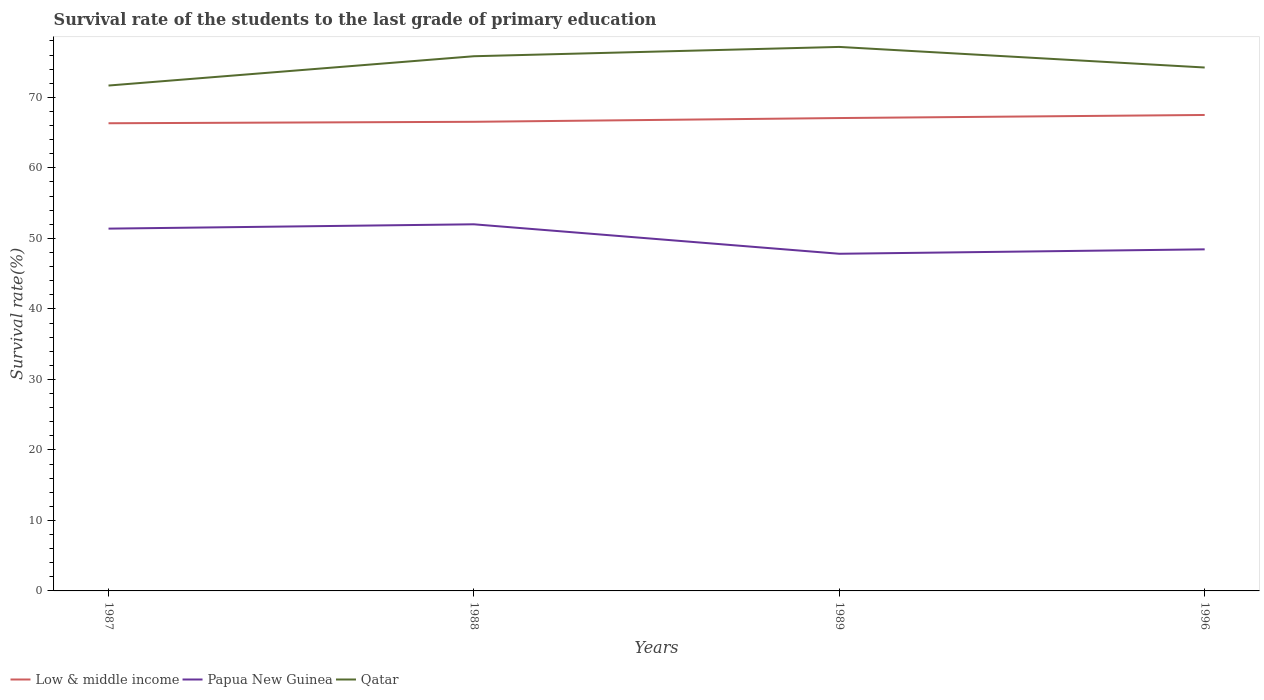Does the line corresponding to Papua New Guinea intersect with the line corresponding to Qatar?
Keep it short and to the point. No. Across all years, what is the maximum survival rate of the students in Qatar?
Your answer should be compact. 71.68. What is the total survival rate of the students in Qatar in the graph?
Offer a very short reply. 1.6. What is the difference between the highest and the second highest survival rate of the students in Papua New Guinea?
Offer a very short reply. 4.18. How many lines are there?
Make the answer very short. 3. What is the difference between two consecutive major ticks on the Y-axis?
Your response must be concise. 10. How many legend labels are there?
Provide a short and direct response. 3. How are the legend labels stacked?
Your answer should be very brief. Horizontal. What is the title of the graph?
Offer a terse response. Survival rate of the students to the last grade of primary education. What is the label or title of the Y-axis?
Your response must be concise. Survival rate(%). What is the Survival rate(%) in Low & middle income in 1987?
Your response must be concise. 66.33. What is the Survival rate(%) in Papua New Guinea in 1987?
Offer a very short reply. 51.39. What is the Survival rate(%) of Qatar in 1987?
Offer a terse response. 71.68. What is the Survival rate(%) in Low & middle income in 1988?
Provide a succinct answer. 66.54. What is the Survival rate(%) of Papua New Guinea in 1988?
Offer a very short reply. 52. What is the Survival rate(%) in Qatar in 1988?
Give a very brief answer. 75.84. What is the Survival rate(%) of Low & middle income in 1989?
Give a very brief answer. 67.07. What is the Survival rate(%) of Papua New Guinea in 1989?
Keep it short and to the point. 47.82. What is the Survival rate(%) of Qatar in 1989?
Keep it short and to the point. 77.16. What is the Survival rate(%) in Low & middle income in 1996?
Your answer should be compact. 67.51. What is the Survival rate(%) of Papua New Guinea in 1996?
Give a very brief answer. 48.45. What is the Survival rate(%) of Qatar in 1996?
Make the answer very short. 74.24. Across all years, what is the maximum Survival rate(%) of Low & middle income?
Your response must be concise. 67.51. Across all years, what is the maximum Survival rate(%) in Papua New Guinea?
Your answer should be very brief. 52. Across all years, what is the maximum Survival rate(%) of Qatar?
Your answer should be compact. 77.16. Across all years, what is the minimum Survival rate(%) in Low & middle income?
Your answer should be very brief. 66.33. Across all years, what is the minimum Survival rate(%) in Papua New Guinea?
Give a very brief answer. 47.82. Across all years, what is the minimum Survival rate(%) of Qatar?
Provide a succinct answer. 71.68. What is the total Survival rate(%) in Low & middle income in the graph?
Offer a terse response. 267.45. What is the total Survival rate(%) in Papua New Guinea in the graph?
Provide a short and direct response. 199.65. What is the total Survival rate(%) in Qatar in the graph?
Your answer should be very brief. 298.92. What is the difference between the Survival rate(%) in Low & middle income in 1987 and that in 1988?
Give a very brief answer. -0.21. What is the difference between the Survival rate(%) of Papua New Guinea in 1987 and that in 1988?
Your answer should be very brief. -0.61. What is the difference between the Survival rate(%) in Qatar in 1987 and that in 1988?
Keep it short and to the point. -4.16. What is the difference between the Survival rate(%) in Low & middle income in 1987 and that in 1989?
Your answer should be very brief. -0.74. What is the difference between the Survival rate(%) of Papua New Guinea in 1987 and that in 1989?
Your response must be concise. 3.57. What is the difference between the Survival rate(%) in Qatar in 1987 and that in 1989?
Provide a succinct answer. -5.48. What is the difference between the Survival rate(%) of Low & middle income in 1987 and that in 1996?
Give a very brief answer. -1.18. What is the difference between the Survival rate(%) in Papua New Guinea in 1987 and that in 1996?
Provide a succinct answer. 2.94. What is the difference between the Survival rate(%) of Qatar in 1987 and that in 1996?
Your answer should be very brief. -2.56. What is the difference between the Survival rate(%) in Low & middle income in 1988 and that in 1989?
Keep it short and to the point. -0.53. What is the difference between the Survival rate(%) of Papua New Guinea in 1988 and that in 1989?
Your response must be concise. 4.18. What is the difference between the Survival rate(%) of Qatar in 1988 and that in 1989?
Your answer should be very brief. -1.32. What is the difference between the Survival rate(%) in Low & middle income in 1988 and that in 1996?
Offer a very short reply. -0.97. What is the difference between the Survival rate(%) in Papua New Guinea in 1988 and that in 1996?
Offer a very short reply. 3.55. What is the difference between the Survival rate(%) of Qatar in 1988 and that in 1996?
Offer a very short reply. 1.6. What is the difference between the Survival rate(%) in Low & middle income in 1989 and that in 1996?
Offer a terse response. -0.44. What is the difference between the Survival rate(%) of Papua New Guinea in 1989 and that in 1996?
Your answer should be compact. -0.63. What is the difference between the Survival rate(%) of Qatar in 1989 and that in 1996?
Offer a terse response. 2.92. What is the difference between the Survival rate(%) of Low & middle income in 1987 and the Survival rate(%) of Papua New Guinea in 1988?
Your answer should be very brief. 14.33. What is the difference between the Survival rate(%) in Low & middle income in 1987 and the Survival rate(%) in Qatar in 1988?
Offer a terse response. -9.51. What is the difference between the Survival rate(%) in Papua New Guinea in 1987 and the Survival rate(%) in Qatar in 1988?
Provide a succinct answer. -24.45. What is the difference between the Survival rate(%) of Low & middle income in 1987 and the Survival rate(%) of Papua New Guinea in 1989?
Give a very brief answer. 18.51. What is the difference between the Survival rate(%) of Low & middle income in 1987 and the Survival rate(%) of Qatar in 1989?
Your answer should be very brief. -10.83. What is the difference between the Survival rate(%) of Papua New Guinea in 1987 and the Survival rate(%) of Qatar in 1989?
Your answer should be very brief. -25.77. What is the difference between the Survival rate(%) in Low & middle income in 1987 and the Survival rate(%) in Papua New Guinea in 1996?
Keep it short and to the point. 17.88. What is the difference between the Survival rate(%) in Low & middle income in 1987 and the Survival rate(%) in Qatar in 1996?
Your response must be concise. -7.91. What is the difference between the Survival rate(%) of Papua New Guinea in 1987 and the Survival rate(%) of Qatar in 1996?
Provide a short and direct response. -22.85. What is the difference between the Survival rate(%) in Low & middle income in 1988 and the Survival rate(%) in Papua New Guinea in 1989?
Keep it short and to the point. 18.72. What is the difference between the Survival rate(%) in Low & middle income in 1988 and the Survival rate(%) in Qatar in 1989?
Make the answer very short. -10.62. What is the difference between the Survival rate(%) of Papua New Guinea in 1988 and the Survival rate(%) of Qatar in 1989?
Make the answer very short. -25.16. What is the difference between the Survival rate(%) in Low & middle income in 1988 and the Survival rate(%) in Papua New Guinea in 1996?
Provide a short and direct response. 18.09. What is the difference between the Survival rate(%) in Low & middle income in 1988 and the Survival rate(%) in Qatar in 1996?
Your answer should be compact. -7.7. What is the difference between the Survival rate(%) of Papua New Guinea in 1988 and the Survival rate(%) of Qatar in 1996?
Make the answer very short. -22.24. What is the difference between the Survival rate(%) of Low & middle income in 1989 and the Survival rate(%) of Papua New Guinea in 1996?
Provide a succinct answer. 18.62. What is the difference between the Survival rate(%) in Low & middle income in 1989 and the Survival rate(%) in Qatar in 1996?
Give a very brief answer. -7.17. What is the difference between the Survival rate(%) in Papua New Guinea in 1989 and the Survival rate(%) in Qatar in 1996?
Your answer should be compact. -26.42. What is the average Survival rate(%) in Low & middle income per year?
Provide a succinct answer. 66.86. What is the average Survival rate(%) in Papua New Guinea per year?
Make the answer very short. 49.91. What is the average Survival rate(%) in Qatar per year?
Your response must be concise. 74.73. In the year 1987, what is the difference between the Survival rate(%) in Low & middle income and Survival rate(%) in Papua New Guinea?
Make the answer very short. 14.95. In the year 1987, what is the difference between the Survival rate(%) in Low & middle income and Survival rate(%) in Qatar?
Provide a succinct answer. -5.35. In the year 1987, what is the difference between the Survival rate(%) in Papua New Guinea and Survival rate(%) in Qatar?
Your response must be concise. -20.29. In the year 1988, what is the difference between the Survival rate(%) in Low & middle income and Survival rate(%) in Papua New Guinea?
Offer a very short reply. 14.54. In the year 1988, what is the difference between the Survival rate(%) of Low & middle income and Survival rate(%) of Qatar?
Provide a succinct answer. -9.3. In the year 1988, what is the difference between the Survival rate(%) in Papua New Guinea and Survival rate(%) in Qatar?
Your answer should be compact. -23.84. In the year 1989, what is the difference between the Survival rate(%) of Low & middle income and Survival rate(%) of Papua New Guinea?
Ensure brevity in your answer.  19.25. In the year 1989, what is the difference between the Survival rate(%) of Low & middle income and Survival rate(%) of Qatar?
Provide a succinct answer. -10.09. In the year 1989, what is the difference between the Survival rate(%) in Papua New Guinea and Survival rate(%) in Qatar?
Keep it short and to the point. -29.34. In the year 1996, what is the difference between the Survival rate(%) of Low & middle income and Survival rate(%) of Papua New Guinea?
Provide a short and direct response. 19.06. In the year 1996, what is the difference between the Survival rate(%) of Low & middle income and Survival rate(%) of Qatar?
Ensure brevity in your answer.  -6.73. In the year 1996, what is the difference between the Survival rate(%) in Papua New Guinea and Survival rate(%) in Qatar?
Offer a terse response. -25.79. What is the ratio of the Survival rate(%) of Low & middle income in 1987 to that in 1988?
Provide a short and direct response. 1. What is the ratio of the Survival rate(%) of Papua New Guinea in 1987 to that in 1988?
Ensure brevity in your answer.  0.99. What is the ratio of the Survival rate(%) in Qatar in 1987 to that in 1988?
Keep it short and to the point. 0.95. What is the ratio of the Survival rate(%) in Low & middle income in 1987 to that in 1989?
Your answer should be compact. 0.99. What is the ratio of the Survival rate(%) of Papua New Guinea in 1987 to that in 1989?
Your answer should be compact. 1.07. What is the ratio of the Survival rate(%) in Qatar in 1987 to that in 1989?
Your answer should be compact. 0.93. What is the ratio of the Survival rate(%) of Low & middle income in 1987 to that in 1996?
Ensure brevity in your answer.  0.98. What is the ratio of the Survival rate(%) in Papua New Guinea in 1987 to that in 1996?
Provide a short and direct response. 1.06. What is the ratio of the Survival rate(%) of Qatar in 1987 to that in 1996?
Your response must be concise. 0.97. What is the ratio of the Survival rate(%) of Papua New Guinea in 1988 to that in 1989?
Your answer should be very brief. 1.09. What is the ratio of the Survival rate(%) in Qatar in 1988 to that in 1989?
Your answer should be very brief. 0.98. What is the ratio of the Survival rate(%) in Low & middle income in 1988 to that in 1996?
Your answer should be very brief. 0.99. What is the ratio of the Survival rate(%) in Papua New Guinea in 1988 to that in 1996?
Give a very brief answer. 1.07. What is the ratio of the Survival rate(%) of Qatar in 1988 to that in 1996?
Offer a terse response. 1.02. What is the ratio of the Survival rate(%) in Low & middle income in 1989 to that in 1996?
Give a very brief answer. 0.99. What is the ratio of the Survival rate(%) of Papua New Guinea in 1989 to that in 1996?
Your response must be concise. 0.99. What is the ratio of the Survival rate(%) in Qatar in 1989 to that in 1996?
Your answer should be compact. 1.04. What is the difference between the highest and the second highest Survival rate(%) of Low & middle income?
Offer a very short reply. 0.44. What is the difference between the highest and the second highest Survival rate(%) in Papua New Guinea?
Provide a short and direct response. 0.61. What is the difference between the highest and the second highest Survival rate(%) of Qatar?
Your answer should be compact. 1.32. What is the difference between the highest and the lowest Survival rate(%) in Low & middle income?
Provide a succinct answer. 1.18. What is the difference between the highest and the lowest Survival rate(%) of Papua New Guinea?
Offer a terse response. 4.18. What is the difference between the highest and the lowest Survival rate(%) in Qatar?
Your response must be concise. 5.48. 